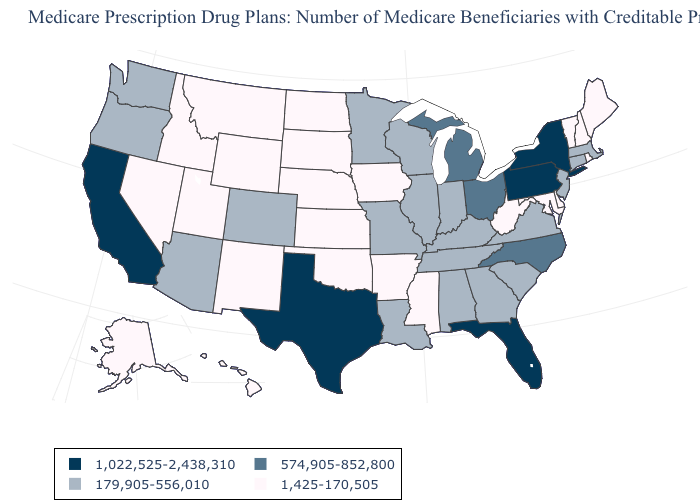Name the states that have a value in the range 1,425-170,505?
Concise answer only. Alaska, Arkansas, Delaware, Hawaii, Idaho, Iowa, Kansas, Maine, Maryland, Mississippi, Montana, Nebraska, Nevada, New Hampshire, New Mexico, North Dakota, Oklahoma, Rhode Island, South Dakota, Utah, Vermont, West Virginia, Wyoming. What is the value of Louisiana?
Quick response, please. 179,905-556,010. What is the value of Maryland?
Short answer required. 1,425-170,505. Name the states that have a value in the range 574,905-852,800?
Answer briefly. Michigan, North Carolina, Ohio. Does Mississippi have the same value as Louisiana?
Give a very brief answer. No. What is the highest value in the West ?
Short answer required. 1,022,525-2,438,310. What is the highest value in states that border Indiana?
Write a very short answer. 574,905-852,800. Among the states that border South Dakota , does Minnesota have the highest value?
Short answer required. Yes. What is the lowest value in the USA?
Answer briefly. 1,425-170,505. Among the states that border Tennessee , does North Carolina have the highest value?
Answer briefly. Yes. Does Oregon have a higher value than Pennsylvania?
Write a very short answer. No. What is the highest value in the USA?
Be succinct. 1,022,525-2,438,310. Which states hav the highest value in the Northeast?
Short answer required. New York, Pennsylvania. Does the map have missing data?
Give a very brief answer. No. Among the states that border California , does Oregon have the lowest value?
Give a very brief answer. No. 